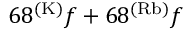<formula> <loc_0><loc_0><loc_500><loc_500>6 8 ^ { ( K ) } f + 6 8 ^ { ( R b ) } f</formula> 